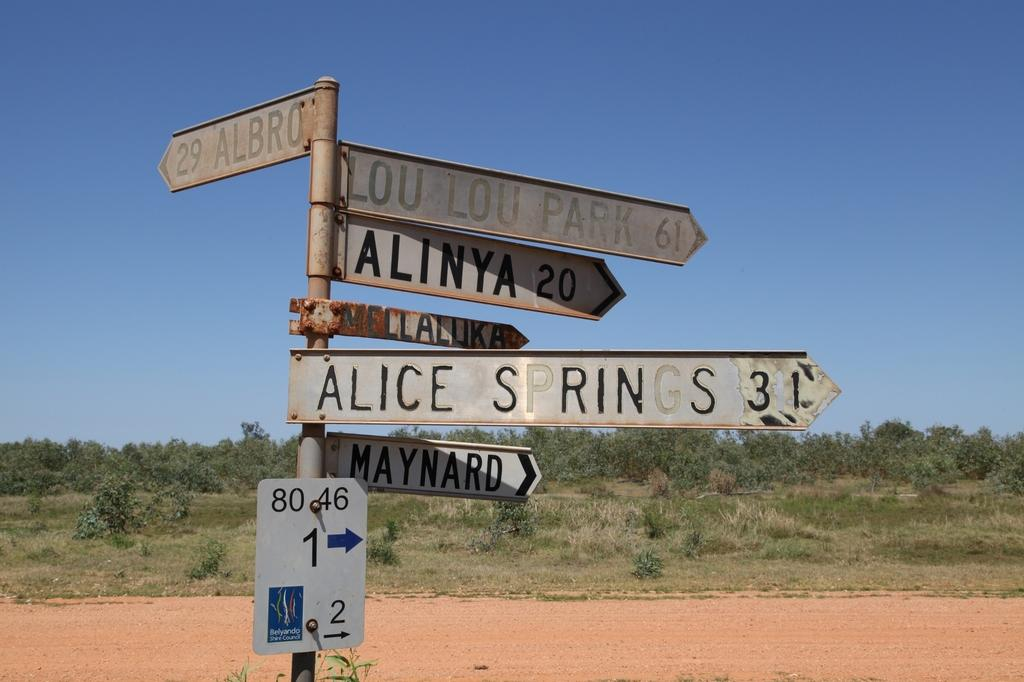<image>
Give a short and clear explanation of the subsequent image. A sign showing the distance to Alice Springs and Maynard stands in the desert. 